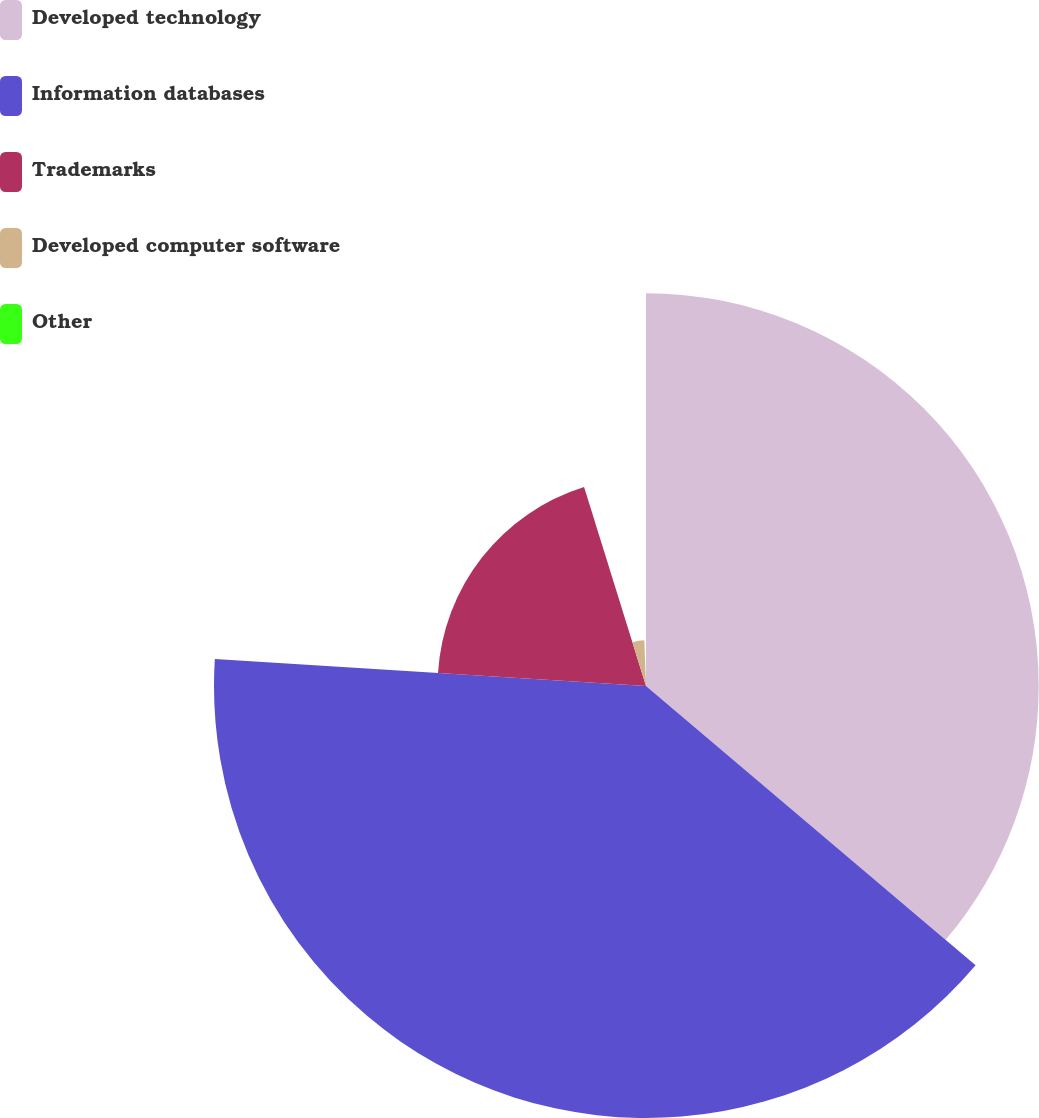Convert chart to OTSL. <chart><loc_0><loc_0><loc_500><loc_500><pie_chart><fcel>Developed technology<fcel>Information databases<fcel>Trademarks<fcel>Developed computer software<fcel>Other<nl><fcel>36.18%<fcel>39.8%<fcel>19.2%<fcel>4.21%<fcel>0.59%<nl></chart> 